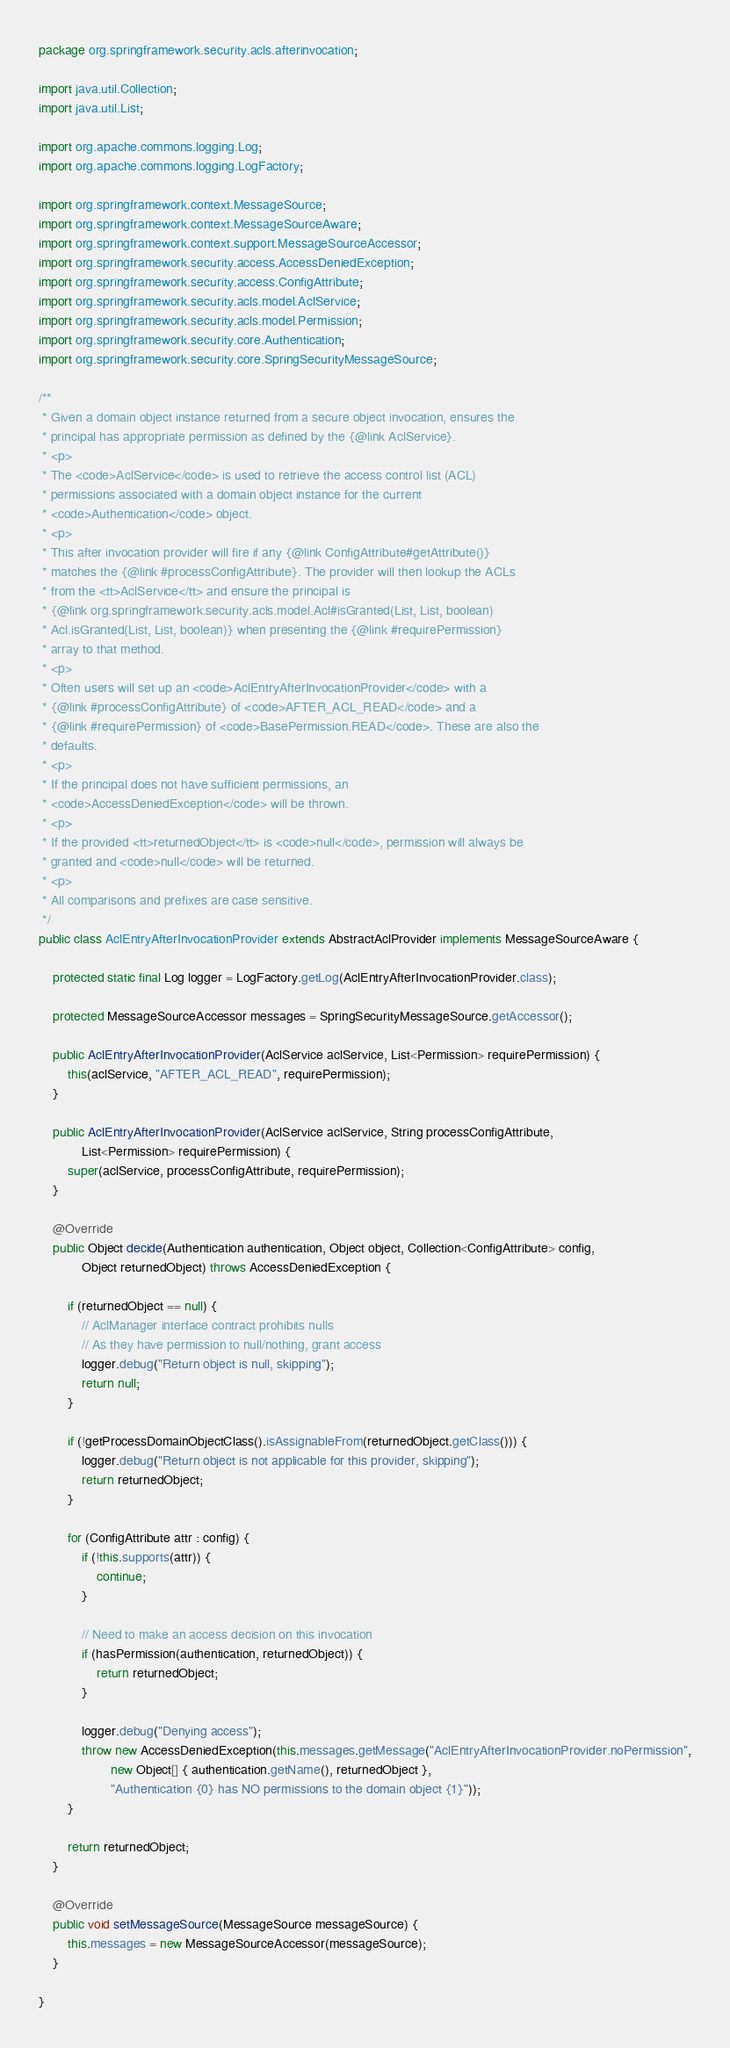<code> <loc_0><loc_0><loc_500><loc_500><_Java_>package org.springframework.security.acls.afterinvocation;

import java.util.Collection;
import java.util.List;

import org.apache.commons.logging.Log;
import org.apache.commons.logging.LogFactory;

import org.springframework.context.MessageSource;
import org.springframework.context.MessageSourceAware;
import org.springframework.context.support.MessageSourceAccessor;
import org.springframework.security.access.AccessDeniedException;
import org.springframework.security.access.ConfigAttribute;
import org.springframework.security.acls.model.AclService;
import org.springframework.security.acls.model.Permission;
import org.springframework.security.core.Authentication;
import org.springframework.security.core.SpringSecurityMessageSource;

/**
 * Given a domain object instance returned from a secure object invocation, ensures the
 * principal has appropriate permission as defined by the {@link AclService}.
 * <p>
 * The <code>AclService</code> is used to retrieve the access control list (ACL)
 * permissions associated with a domain object instance for the current
 * <code>Authentication</code> object.
 * <p>
 * This after invocation provider will fire if any {@link ConfigAttribute#getAttribute()}
 * matches the {@link #processConfigAttribute}. The provider will then lookup the ACLs
 * from the <tt>AclService</tt> and ensure the principal is
 * {@link org.springframework.security.acls.model.Acl#isGranted(List, List, boolean)
 * Acl.isGranted(List, List, boolean)} when presenting the {@link #requirePermission}
 * array to that method.
 * <p>
 * Often users will set up an <code>AclEntryAfterInvocationProvider</code> with a
 * {@link #processConfigAttribute} of <code>AFTER_ACL_READ</code> and a
 * {@link #requirePermission} of <code>BasePermission.READ</code>. These are also the
 * defaults.
 * <p>
 * If the principal does not have sufficient permissions, an
 * <code>AccessDeniedException</code> will be thrown.
 * <p>
 * If the provided <tt>returnedObject</tt> is <code>null</code>, permission will always be
 * granted and <code>null</code> will be returned.
 * <p>
 * All comparisons and prefixes are case sensitive.
 */
public class AclEntryAfterInvocationProvider extends AbstractAclProvider implements MessageSourceAware {

	protected static final Log logger = LogFactory.getLog(AclEntryAfterInvocationProvider.class);

	protected MessageSourceAccessor messages = SpringSecurityMessageSource.getAccessor();

	public AclEntryAfterInvocationProvider(AclService aclService, List<Permission> requirePermission) {
		this(aclService, "AFTER_ACL_READ", requirePermission);
	}

	public AclEntryAfterInvocationProvider(AclService aclService, String processConfigAttribute,
			List<Permission> requirePermission) {
		super(aclService, processConfigAttribute, requirePermission);
	}

	@Override
	public Object decide(Authentication authentication, Object object, Collection<ConfigAttribute> config,
			Object returnedObject) throws AccessDeniedException {

		if (returnedObject == null) {
			// AclManager interface contract prohibits nulls
			// As they have permission to null/nothing, grant access
			logger.debug("Return object is null, skipping");
			return null;
		}

		if (!getProcessDomainObjectClass().isAssignableFrom(returnedObject.getClass())) {
			logger.debug("Return object is not applicable for this provider, skipping");
			return returnedObject;
		}

		for (ConfigAttribute attr : config) {
			if (!this.supports(attr)) {
				continue;
			}

			// Need to make an access decision on this invocation
			if (hasPermission(authentication, returnedObject)) {
				return returnedObject;
			}

			logger.debug("Denying access");
			throw new AccessDeniedException(this.messages.getMessage("AclEntryAfterInvocationProvider.noPermission",
					new Object[] { authentication.getName(), returnedObject },
					"Authentication {0} has NO permissions to the domain object {1}"));
		}

		return returnedObject;
	}

	@Override
	public void setMessageSource(MessageSource messageSource) {
		this.messages = new MessageSourceAccessor(messageSource);
	}

}
</code> 